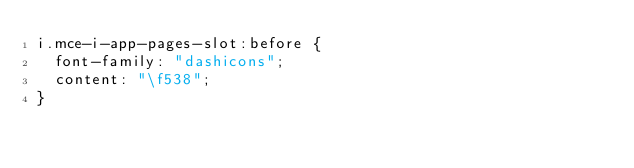<code> <loc_0><loc_0><loc_500><loc_500><_CSS_>i.mce-i-app-pages-slot:before {
  font-family: "dashicons";
  content: "\f538";
}
</code> 